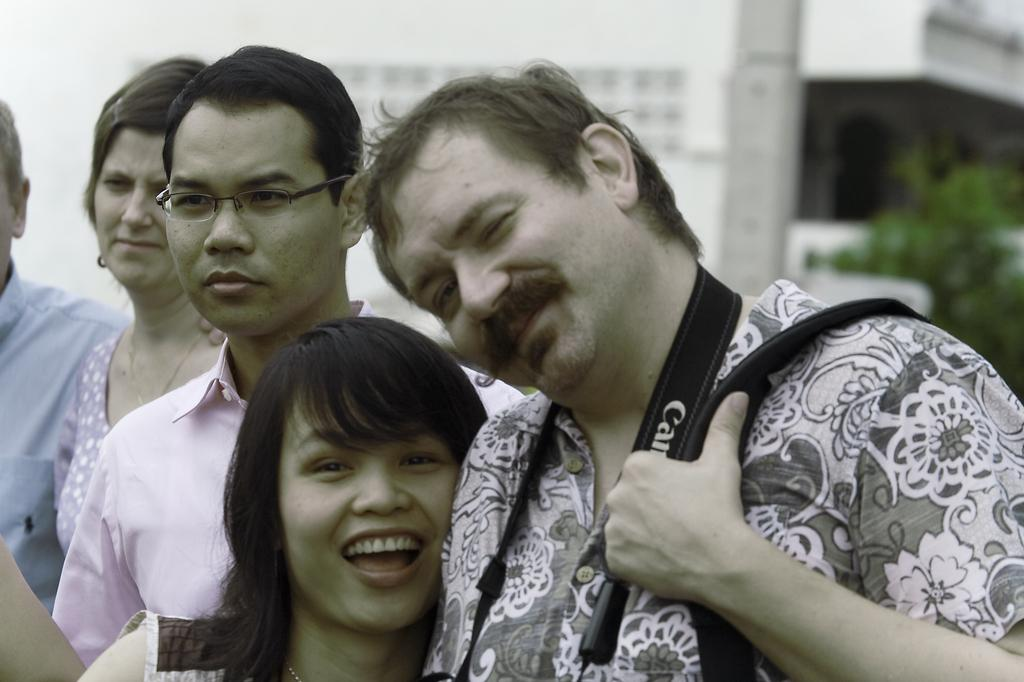What is happening in the image? There are people standing in the image. Can you describe what one of the people is holding? A man is holding a bag in his hand. What can be seen in the distance behind the people? There is a building and a tree in the background of the image. What type of cable is being used by the people in the image? There is no cable visible in the image; it only shows people standing and a man holding a bag. What kind of shoes are the people wearing in the image? The image does not provide enough detail to determine the type of shoes the people are wearing. 